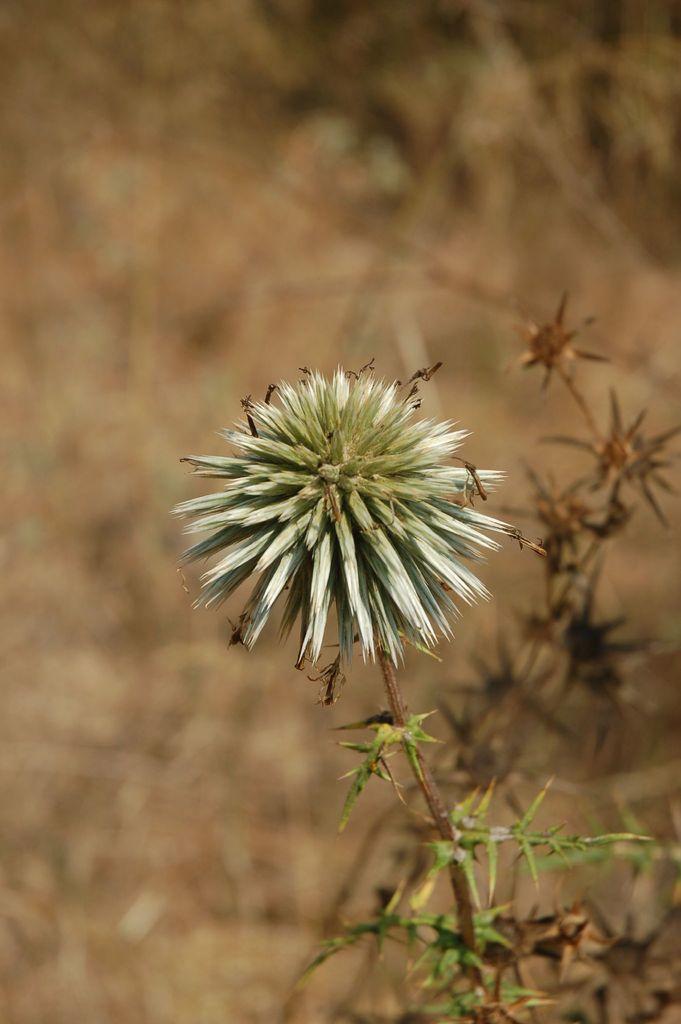How would you summarize this image in a sentence or two? In the image we can see some plants and flowers. Background of the image is blur. 